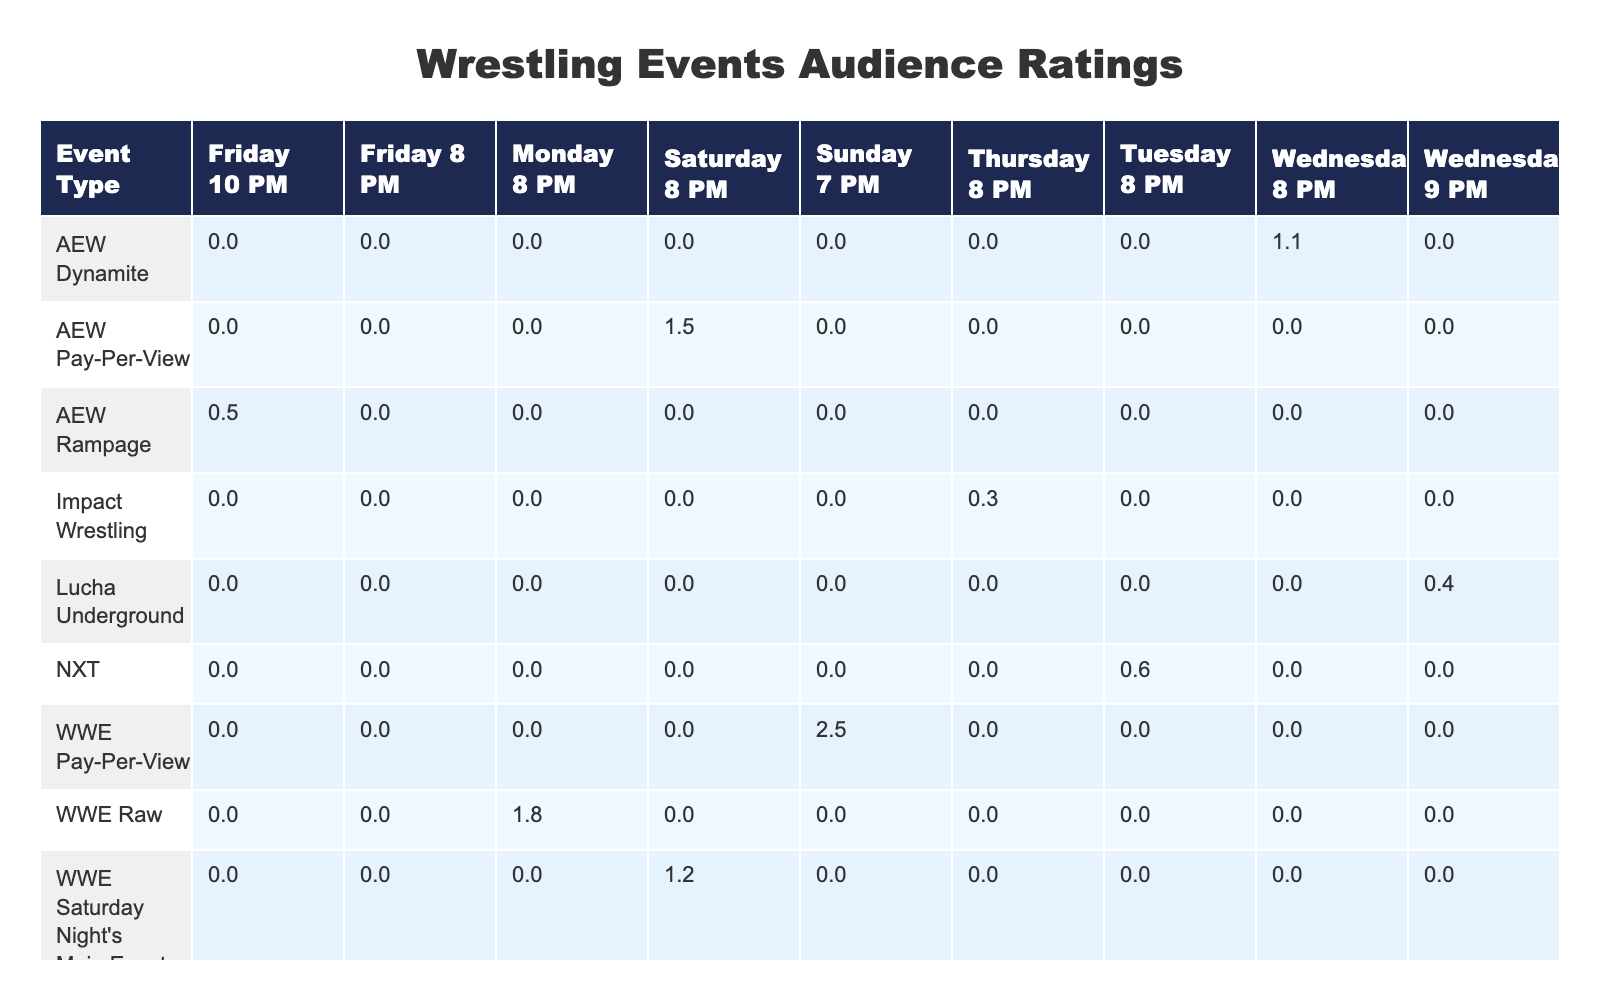What is the highest audience rating among the events listed? The table shows the audience ratings for different events. By scanning through the ratings, the highest value is found for WWE Pay-Per-View at 2.5.
Answer: 2.5 How many events have ratings above 1.0? The ratings above 1.0 are for WWE Raw (1.8), WWE SmackDown (2.0), WWE Pay-Per-View (2.5), and AEW Pay-Per-View (1.5). Counting these, there are 4 events.
Answer: 4 Which event has the lowest audience rating, and what is it? The ratings in the table indicate that Impact Wrestling has the lowest rating of 0.3.
Answer: Impact Wrestling, 0.3 What is the average audience rating for events in the 8 PM time slot? The events at 8 PM are WWE Raw (1.8), WWE SmackDown (2.0), AEW Dynamite (1.1), NXT (0.6), WWE Saturday Night's Main Event (1.2), and AEW Rampage (0.5). First, add these ratings: 1.8 + 2.0 + 1.1 + 0.6 + 1.2 + 0.5 = 7.2. There are 6 events, so the average is 7.2 / 6 = 1.2.
Answer: 1.2 Are there any events with audience ratings below 0.5? The table indicates that both Impact Wrestling (0.3) and Lucha Underground (0.4) have ratings below 0.5. Therefore, the answer is yes.
Answer: Yes What is the difference in audience ratings between the highest-rated and the lowest-rated event? The highest-rated event is WWE Pay-Per-View (2.5), while the lowest is Impact Wrestling (0.3). The difference between them is calculated as 2.5 - 0.3 = 2.2.
Answer: 2.2 Which time slot has the highest average audience rating? To find this, calculate the average ratings for each time slot. For Monday 8 PM: 1.8; Friday 8 PM: 2.0 (only WWE SmackDown); Wednesday 8 PM: 1.1 (only AEW Dynamite); Tuesday 8 PM: 0.6 (only NXT); Thursday 8 PM: 0.3 (only Impact Wrestling); and Saturday 8 PM: (1.5 + 1.2) / 2 = 1.35. The highest average is for Friday 8 PM with a rating of 2.0.
Answer: Friday 8 PM Is WWE Raw's audience rating higher than AEW Dynamite's? WWE Raw has an audience rating of 1.8, while AEW Dynamite has a rating of 1.1. Because 1.8 is greater than 1.1, WWE Raw's rating is indeed higher.
Answer: Yes How many events have ratings that are equal to or less than 0.5? From the table, only Impact Wrestling (0.3) and Lucha Underground (0.4) have ratings equal to or less than 0.5. Thus, there are 2 events.
Answer: 2 